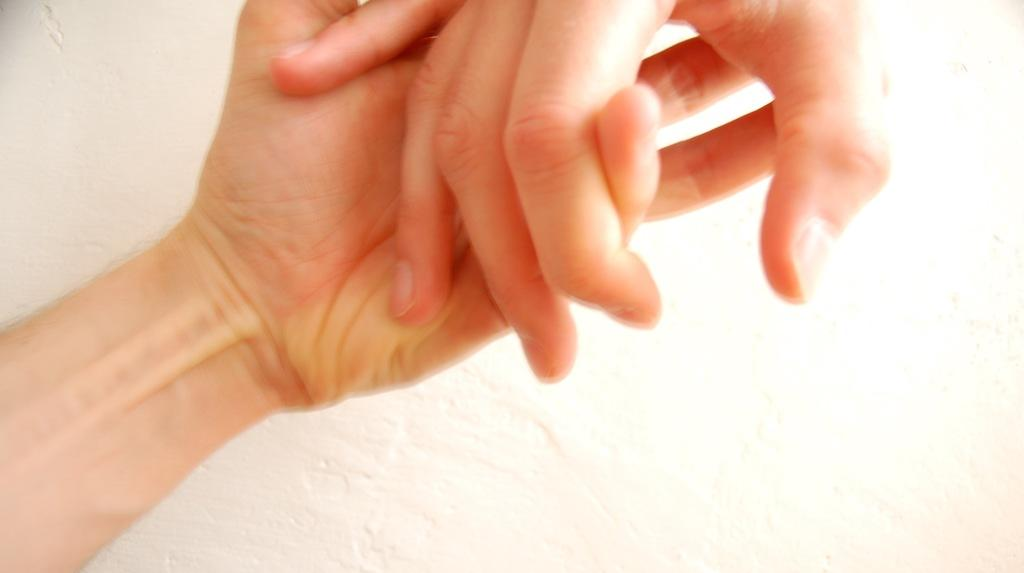How many people are in the image? There are two persons in the image. What are the two persons doing in the image? The two persons are holding hands of each other. What type of cherry is being used as a weight in the image? There is no cherry or weight present in the image; the two persons are simply holding hands. 